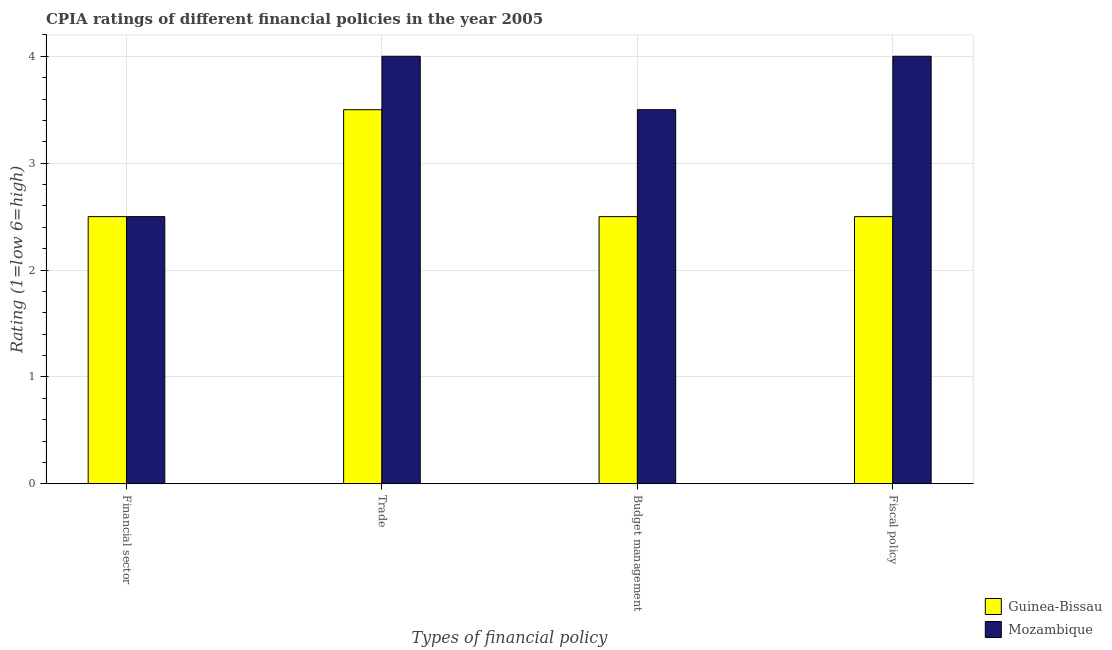How many bars are there on the 1st tick from the right?
Give a very brief answer. 2. What is the label of the 1st group of bars from the left?
Give a very brief answer. Financial sector. What is the cpia rating of financial sector in Guinea-Bissau?
Your answer should be very brief. 2.5. Across all countries, what is the minimum cpia rating of trade?
Offer a very short reply. 3.5. In which country was the cpia rating of budget management maximum?
Make the answer very short. Mozambique. In which country was the cpia rating of financial sector minimum?
Your response must be concise. Guinea-Bissau. What is the total cpia rating of financial sector in the graph?
Your answer should be very brief. 5. What is the difference between the cpia rating of budget management in Guinea-Bissau and that in Mozambique?
Make the answer very short. -1. What is the difference between the cpia rating of budget management in Guinea-Bissau and the cpia rating of financial sector in Mozambique?
Your response must be concise. 0. What is the average cpia rating of fiscal policy per country?
Your response must be concise. 3.25. What is the difference between the cpia rating of fiscal policy and cpia rating of financial sector in Guinea-Bissau?
Ensure brevity in your answer.  0. In how many countries, is the cpia rating of financial sector greater than 3.8 ?
Give a very brief answer. 0. Is the difference between the cpia rating of financial sector in Guinea-Bissau and Mozambique greater than the difference between the cpia rating of trade in Guinea-Bissau and Mozambique?
Ensure brevity in your answer.  Yes. What is the difference between the highest and the second highest cpia rating of financial sector?
Your answer should be very brief. 0. In how many countries, is the cpia rating of fiscal policy greater than the average cpia rating of fiscal policy taken over all countries?
Offer a very short reply. 1. Is the sum of the cpia rating of budget management in Guinea-Bissau and Mozambique greater than the maximum cpia rating of financial sector across all countries?
Your answer should be compact. Yes. What does the 1st bar from the left in Fiscal policy represents?
Ensure brevity in your answer.  Guinea-Bissau. What does the 2nd bar from the right in Trade represents?
Keep it short and to the point. Guinea-Bissau. Is it the case that in every country, the sum of the cpia rating of financial sector and cpia rating of trade is greater than the cpia rating of budget management?
Offer a terse response. Yes. How many bars are there?
Offer a terse response. 8. How many countries are there in the graph?
Ensure brevity in your answer.  2. What is the difference between two consecutive major ticks on the Y-axis?
Keep it short and to the point. 1. Does the graph contain any zero values?
Keep it short and to the point. No. Where does the legend appear in the graph?
Offer a terse response. Bottom right. What is the title of the graph?
Provide a short and direct response. CPIA ratings of different financial policies in the year 2005. Does "Brunei Darussalam" appear as one of the legend labels in the graph?
Your answer should be compact. No. What is the label or title of the X-axis?
Ensure brevity in your answer.  Types of financial policy. What is the label or title of the Y-axis?
Your answer should be compact. Rating (1=low 6=high). What is the Rating (1=low 6=high) of Guinea-Bissau in Budget management?
Provide a short and direct response. 2.5. What is the Rating (1=low 6=high) in Mozambique in Fiscal policy?
Keep it short and to the point. 4. Across all Types of financial policy, what is the maximum Rating (1=low 6=high) of Guinea-Bissau?
Your answer should be compact. 3.5. Across all Types of financial policy, what is the maximum Rating (1=low 6=high) in Mozambique?
Offer a very short reply. 4. Across all Types of financial policy, what is the minimum Rating (1=low 6=high) in Mozambique?
Provide a succinct answer. 2.5. What is the total Rating (1=low 6=high) in Guinea-Bissau in the graph?
Offer a very short reply. 11. What is the difference between the Rating (1=low 6=high) of Guinea-Bissau in Financial sector and that in Trade?
Provide a succinct answer. -1. What is the difference between the Rating (1=low 6=high) of Guinea-Bissau in Financial sector and that in Budget management?
Keep it short and to the point. 0. What is the difference between the Rating (1=low 6=high) of Guinea-Bissau in Financial sector and that in Fiscal policy?
Make the answer very short. 0. What is the difference between the Rating (1=low 6=high) of Mozambique in Financial sector and that in Fiscal policy?
Your answer should be very brief. -1.5. What is the difference between the Rating (1=low 6=high) in Mozambique in Trade and that in Budget management?
Ensure brevity in your answer.  0.5. What is the difference between the Rating (1=low 6=high) in Mozambique in Budget management and that in Fiscal policy?
Your answer should be very brief. -0.5. What is the difference between the Rating (1=low 6=high) of Guinea-Bissau in Financial sector and the Rating (1=low 6=high) of Mozambique in Trade?
Provide a succinct answer. -1.5. What is the difference between the Rating (1=low 6=high) of Guinea-Bissau in Financial sector and the Rating (1=low 6=high) of Mozambique in Budget management?
Your response must be concise. -1. What is the difference between the Rating (1=low 6=high) of Guinea-Bissau in Financial sector and the Rating (1=low 6=high) of Mozambique in Fiscal policy?
Ensure brevity in your answer.  -1.5. What is the difference between the Rating (1=low 6=high) in Guinea-Bissau in Trade and the Rating (1=low 6=high) in Mozambique in Budget management?
Your response must be concise. 0. What is the difference between the Rating (1=low 6=high) in Guinea-Bissau in Trade and the Rating (1=low 6=high) in Mozambique in Fiscal policy?
Make the answer very short. -0.5. What is the average Rating (1=low 6=high) of Guinea-Bissau per Types of financial policy?
Provide a succinct answer. 2.75. What is the difference between the Rating (1=low 6=high) in Guinea-Bissau and Rating (1=low 6=high) in Mozambique in Budget management?
Your response must be concise. -1. What is the ratio of the Rating (1=low 6=high) of Mozambique in Financial sector to that in Trade?
Make the answer very short. 0.62. What is the ratio of the Rating (1=low 6=high) of Guinea-Bissau in Financial sector to that in Budget management?
Your response must be concise. 1. What is the ratio of the Rating (1=low 6=high) in Mozambique in Financial sector to that in Budget management?
Ensure brevity in your answer.  0.71. What is the ratio of the Rating (1=low 6=high) of Guinea-Bissau in Financial sector to that in Fiscal policy?
Keep it short and to the point. 1. What is the ratio of the Rating (1=low 6=high) in Mozambique in Trade to that in Fiscal policy?
Your answer should be very brief. 1. What is the difference between the highest and the lowest Rating (1=low 6=high) in Guinea-Bissau?
Your response must be concise. 1. What is the difference between the highest and the lowest Rating (1=low 6=high) in Mozambique?
Your response must be concise. 1.5. 